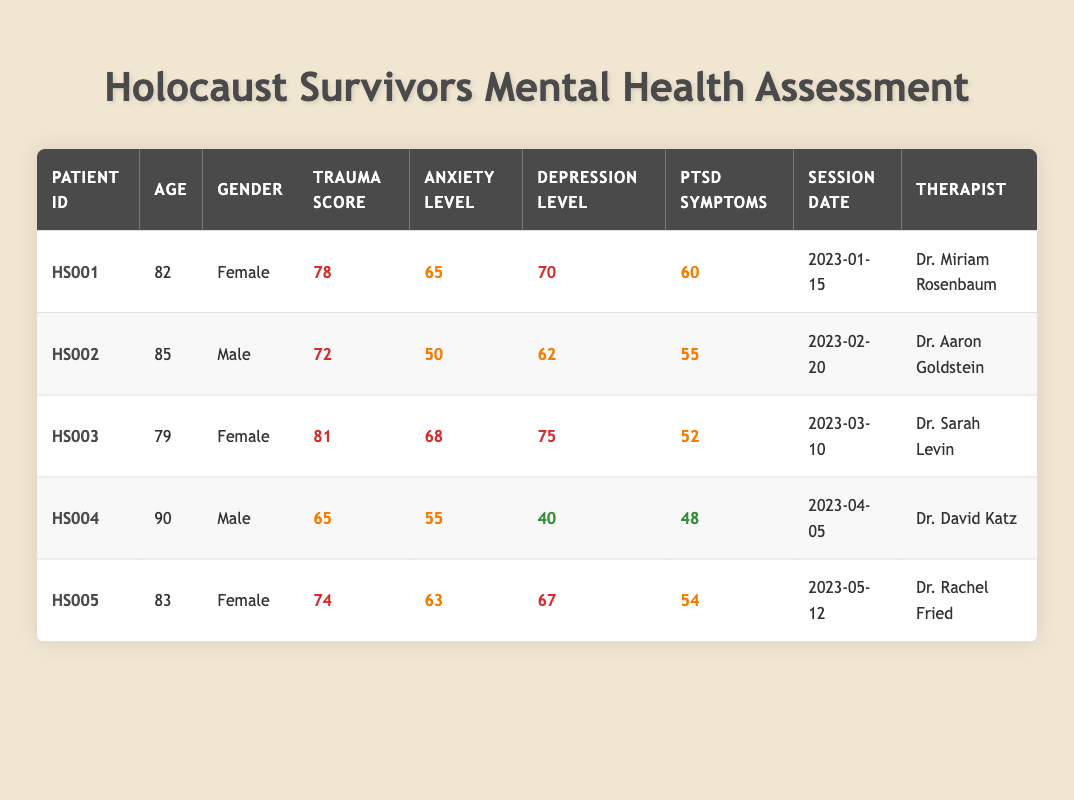What is the trauma score of patient HS003? The table shows a specific column for "Trauma Score." By looking at the row for patient HS003, we can see that the trauma score is listed as 81.
Answer: 81 What is the age of the youngest patient in the table? The ages listed in the table are 82, 85, 79, 90, and 83. The youngest age is 79, associated with patient HS003.
Answer: 79 Is there a patient with a PTSD symptom score below 50? By reviewing the "PTSD Symptoms" column for all patients, the scores are 60, 55, 52, 48, and 54. None of these scores fall below 50, indicating that there is no patient with a PTSD symptom score below 50.
Answer: No What is the average anxiety level of male patients? The anxiety levels for male patients are 50 (HS002) and 55 (HS004). To find the average, we calculate (50 + 55) / 2 = 105 / 2 = 52.5.
Answer: 52.5 Which therapist has seen the patient with the highest trauma score? The highest trauma score in the table is 81, corresponding to patient HS003, who was seen by Dr. Sarah Levin.
Answer: Dr. Sarah Levin What is the difference between the highest and lowest depression level scores in the table? Reviewing the "Depression Level" column, we identify scores of 70, 62, 75, 40, and 67. The highest score is 75 (HS003) and the lowest is 40 (HS004). The difference is calculated as 75 - 40 = 35.
Answer: 35 Is the anxiety level of patient HS001 higher than that of patient HS002? Patient HS001 has an anxiety level of 65 while patient HS002 has an anxiety level of 50. Since 65 is greater than 50, the statement is true.
Answer: Yes What percentage of patients have a trauma score of 75 or higher? A total of 5 patients are listed: HS001 (78), HS002 (72), HS003 (81), HS004 (65), and HS005 (74). Patients HS001 and HS003 score 75 or higher, so that's 2 out of 5. To find the percentage, we calculate (2 / 5) * 100 = 40%.
Answer: 40% Which patient has the highest level of depression? The depression levels are 70, 62, 75, 40, and 67. The highest level is 75, which corresponds to patient HS003.
Answer: HS003 